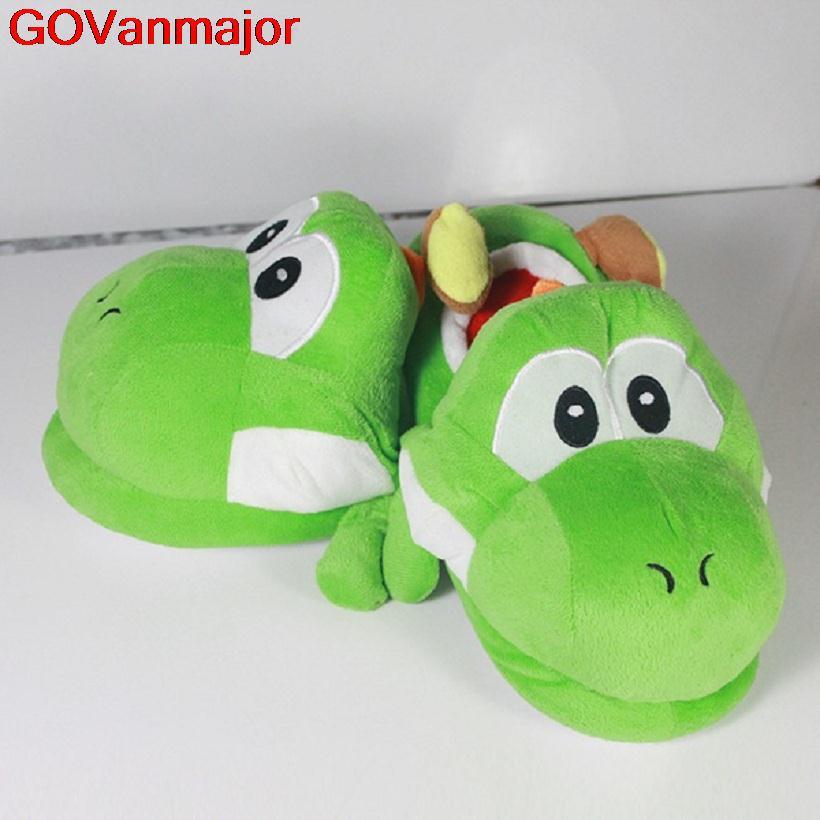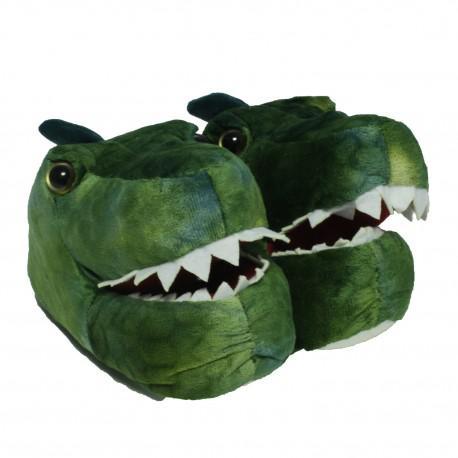The first image is the image on the left, the second image is the image on the right. Assess this claim about the two images: "Three or more slippers in two or more colors resemble animal feet, with plastic toenails protruding from the end of each slipper.". Correct or not? Answer yes or no. No. The first image is the image on the left, the second image is the image on the right. For the images displayed, is the sentence "All slippers are solid colors and have four claws that project outward, but only the right image shows a matched pair of slippers." factually correct? Answer yes or no. No. 